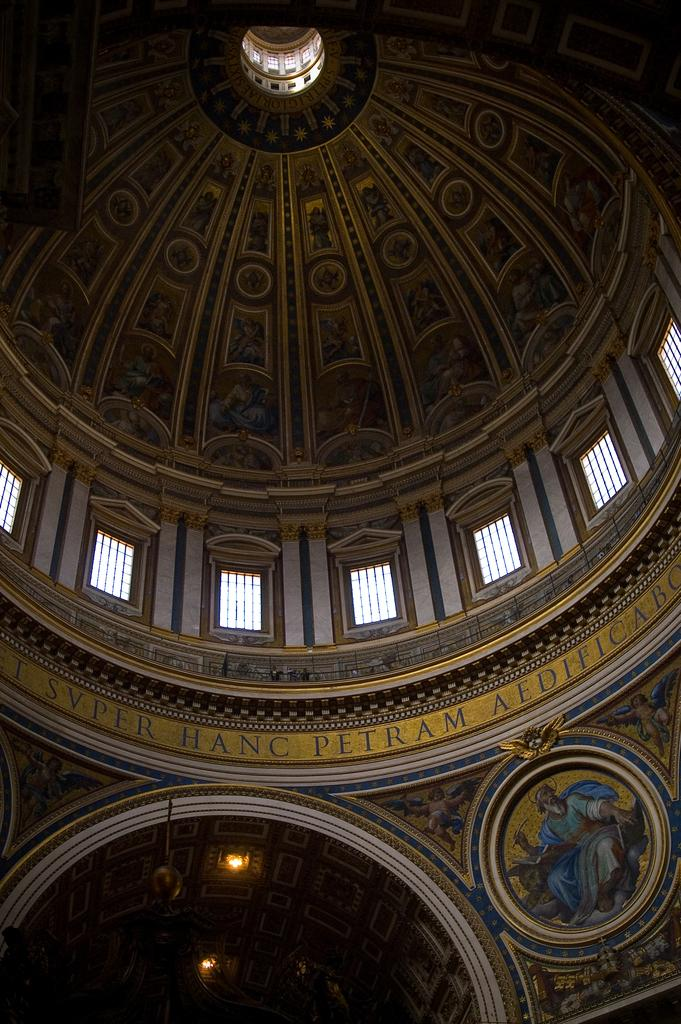What type of view is depicted in the image? The image shows an inner view of a building. What kind of artwork can be seen on the walls? There is a painting on the wall in the image. Are there any paintings on the ceiling? Yes, there is a painting on the ceiling in the image. What else can be seen in the image besides paintings? Text and lights are visible in the image. Can you describe the subject of one of the paintings? There is a painting of a man in the image. How does the person in the painting experience loss in the image? There is no indication of loss or any emotional state in the painting or the image. The painting simply depicts a man, and there is no context provided to suggest any emotional experience. 